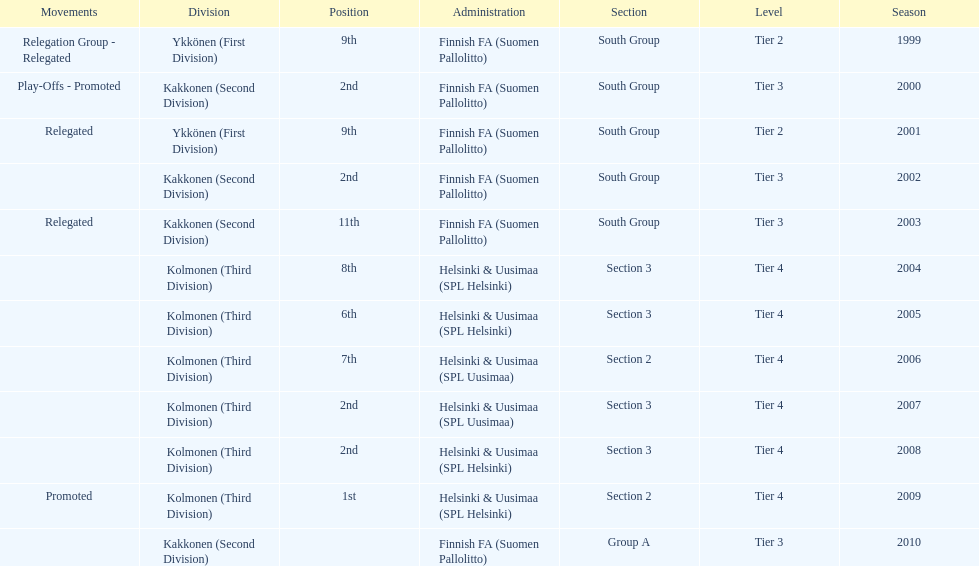Parse the table in full. {'header': ['Movements', 'Division', 'Position', 'Administration', 'Section', 'Level', 'Season'], 'rows': [['Relegation Group - Relegated', 'Ykkönen (First Division)', '9th', 'Finnish FA (Suomen Pallolitto)', 'South Group', 'Tier 2', '1999'], ['Play-Offs - Promoted', 'Kakkonen (Second Division)', '2nd', 'Finnish FA (Suomen Pallolitto)', 'South Group', 'Tier 3', '2000'], ['Relegated', 'Ykkönen (First Division)', '9th', 'Finnish FA (Suomen Pallolitto)', 'South Group', 'Tier 2', '2001'], ['', 'Kakkonen (Second Division)', '2nd', 'Finnish FA (Suomen Pallolitto)', 'South Group', 'Tier 3', '2002'], ['Relegated', 'Kakkonen (Second Division)', '11th', 'Finnish FA (Suomen Pallolitto)', 'South Group', 'Tier 3', '2003'], ['', 'Kolmonen (Third Division)', '8th', 'Helsinki & Uusimaa (SPL Helsinki)', 'Section 3', 'Tier 4', '2004'], ['', 'Kolmonen (Third Division)', '6th', 'Helsinki & Uusimaa (SPL Helsinki)', 'Section 3', 'Tier 4', '2005'], ['', 'Kolmonen (Third Division)', '7th', 'Helsinki & Uusimaa (SPL Uusimaa)', 'Section 2', 'Tier 4', '2006'], ['', 'Kolmonen (Third Division)', '2nd', 'Helsinki & Uusimaa (SPL Uusimaa)', 'Section 3', 'Tier 4', '2007'], ['', 'Kolmonen (Third Division)', '2nd', 'Helsinki & Uusimaa (SPL Helsinki)', 'Section 3', 'Tier 4', '2008'], ['Promoted', 'Kolmonen (Third Division)', '1st', 'Helsinki & Uusimaa (SPL Helsinki)', 'Section 2', 'Tier 4', '2009'], ['', 'Kakkonen (Second Division)', '', 'Finnish FA (Suomen Pallolitto)', 'Group A', 'Tier 3', '2010']]} How many times has this team been relegated? 3. 